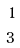Convert formula to latex. <formula><loc_0><loc_0><loc_500><loc_500>1 \\ 3</formula> 